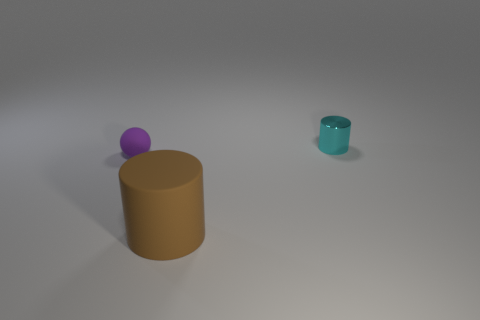Is there any other thing that has the same material as the cyan object?
Ensure brevity in your answer.  No. Is there anything else that is the same size as the matte sphere?
Your answer should be compact. Yes. How many cyan shiny cylinders are behind the cyan metallic object?
Your answer should be compact. 0. There is a tiny object that is right of the matte object that is in front of the purple rubber object; what shape is it?
Provide a short and direct response. Cylinder. Are there any other things that are the same shape as the brown object?
Your answer should be very brief. Yes. Are there more large cylinders left of the small purple rubber sphere than gray metallic things?
Your answer should be very brief. No. There is a thing that is left of the large object; how many brown cylinders are behind it?
Your response must be concise. 0. What shape is the rubber thing to the left of the cylinder in front of the matte thing that is on the left side of the brown cylinder?
Provide a succinct answer. Sphere. The purple sphere is what size?
Your answer should be compact. Small. Are there any large purple cylinders that have the same material as the small purple thing?
Your answer should be very brief. No. 